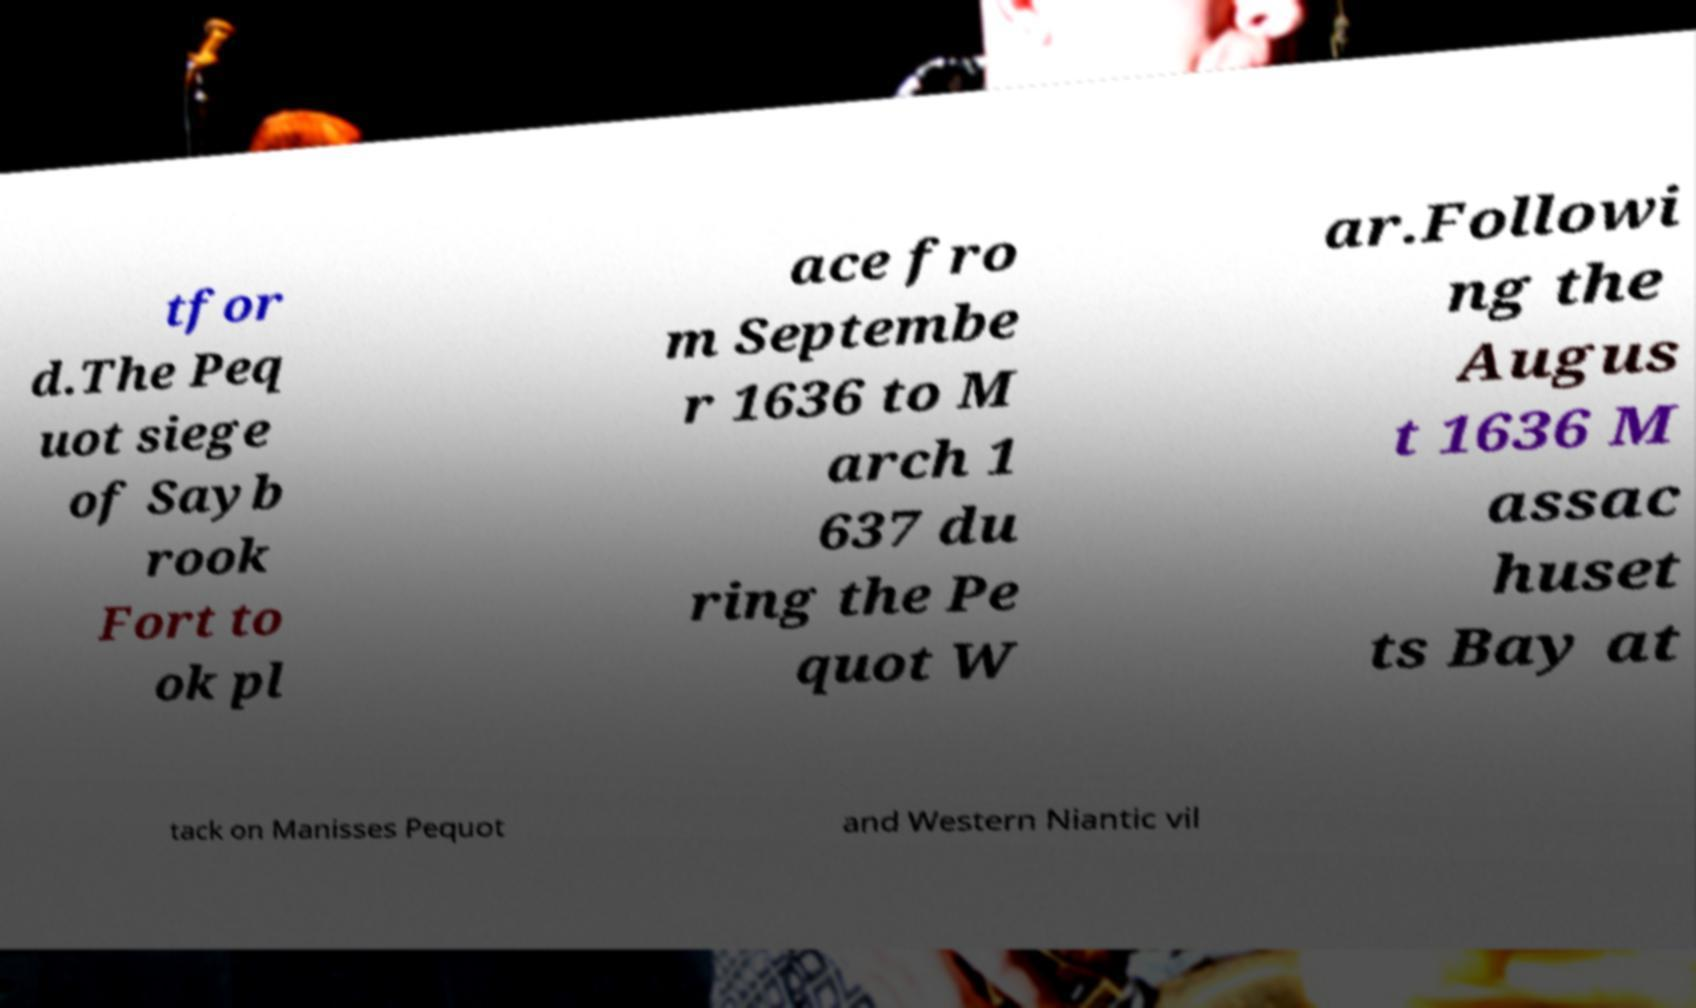Please read and relay the text visible in this image. What does it say? tfor d.The Peq uot siege of Sayb rook Fort to ok pl ace fro m Septembe r 1636 to M arch 1 637 du ring the Pe quot W ar.Followi ng the Augus t 1636 M assac huset ts Bay at tack on Manisses Pequot and Western Niantic vil 